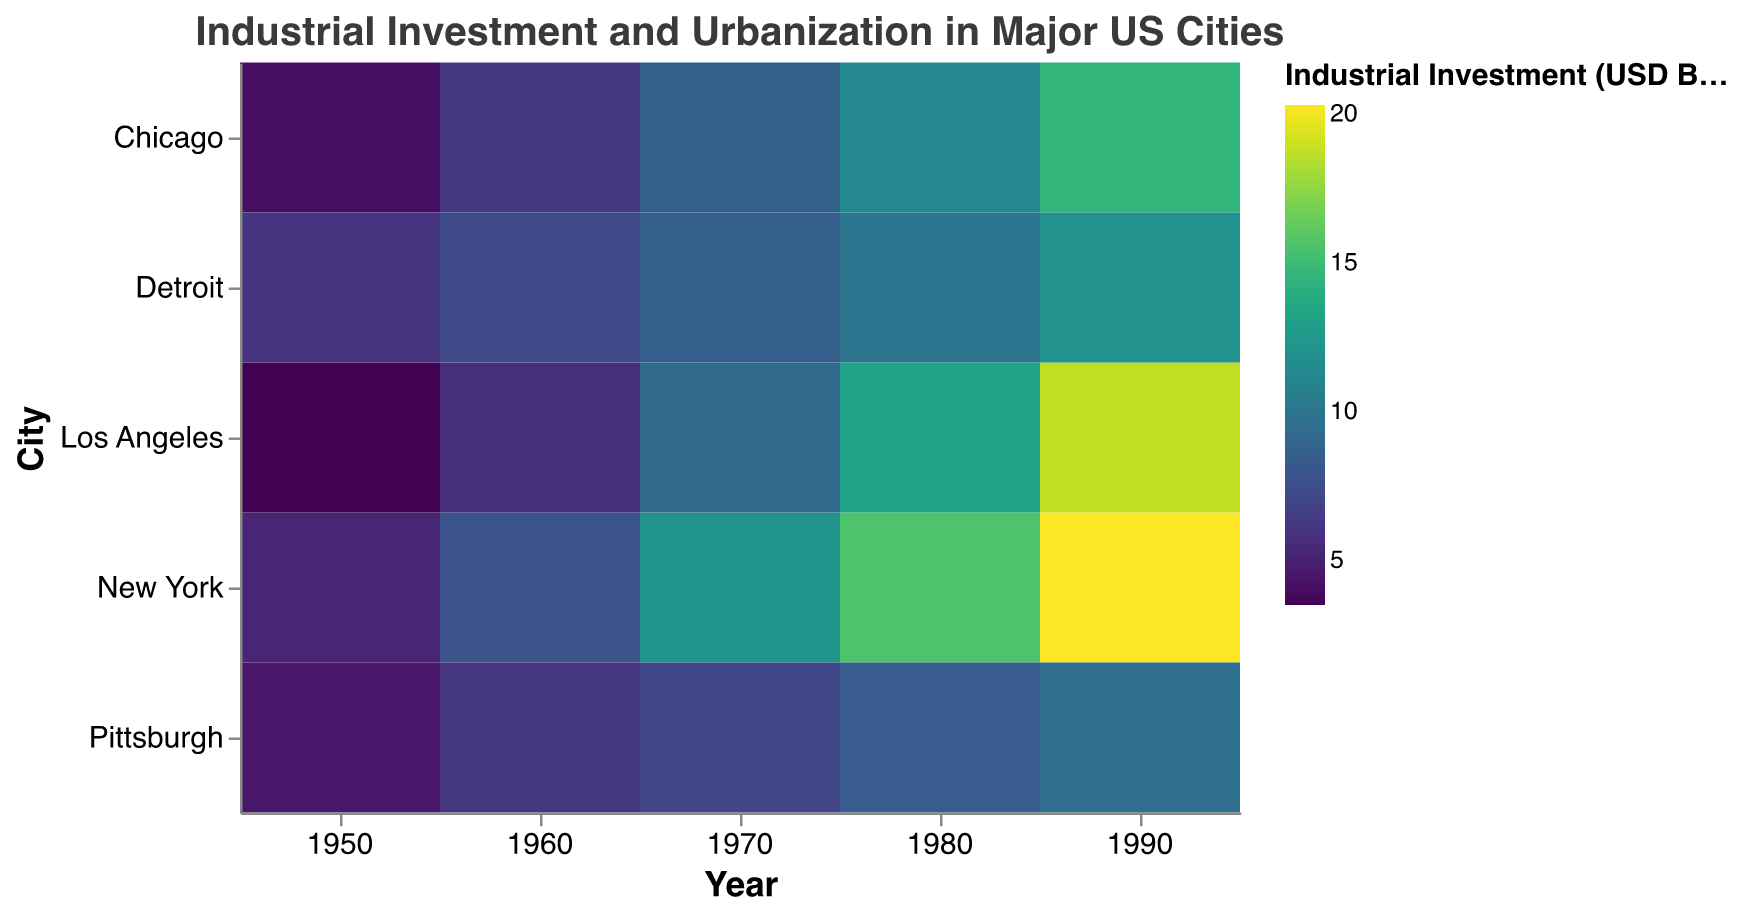What is the title of the heatmap? The title of the heatmap can be found at the top center of the figure and it is specified in the configuration.
Answer: Industrial Investment and Urbanization in Major US Cities How is the urbanization rate represented in the heatmap? The urbanization rate is represented by the size of the rectangles. Larger rectangles indicate higher urbanization rates.
Answer: By size of the rectangles Which city had the highest industrial investment in 1990? Examine the color shade in the 1990 column for the darkest rectangle, which corresponds to the city with the highest industrial investment.
Answer: New York Which city had the lowest urbanization rate in 1950? Inspect the size of the rectangles in the 1950 column to find the smallest rectangle.
Answer: Pittsburgh How did the industrial investment in Chicago change from 1950 to 1990? Compare the color shades in Chicago's row from 1950 to 1990. The color gets progressively darker, indicating an increase in industrial investment.
Answer: It increased Which city experienced the largest increase in urbanization rate from 1950 to 1990? Calculate the urbanization rate difference for each city by finding the size difference of rectangles from 1950 to 1990 and identify the largest difference. New York's urbanization rate increased from 71.3% to 84.7%, which seems to be the largest increase.
Answer: New York Is there a correlation between industrial investment and urbanization rate? Generally, darker rectangles (higher investment) seem to correspond with larger rectangles (higher urbanization rates).
Answer: Yes, a positive correlation How does Los Angeles' industrial investment in 1970 compare to Detroit's in the same year? Compare the color shades of the rectangles in the 1970 column for Los Angeles and Detroit. Los Angeles has a darker shade than Detroit.
Answer: Los Angeles had higher investment 